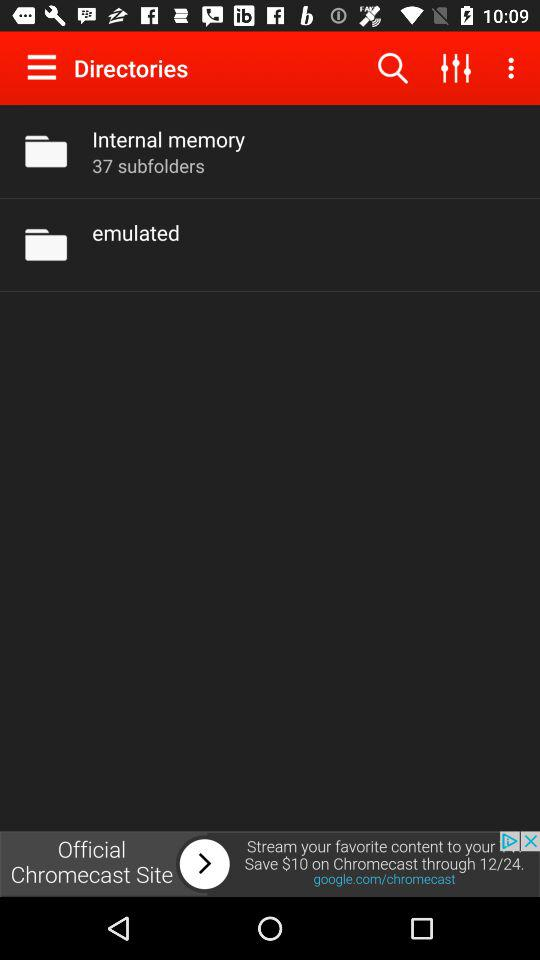How many subfolders are there in total?
Answer the question using a single word or phrase. 37 